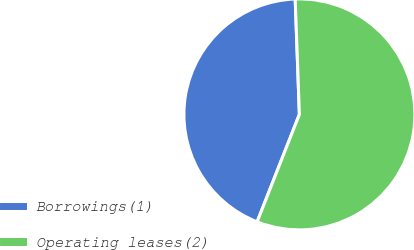Convert chart. <chart><loc_0><loc_0><loc_500><loc_500><pie_chart><fcel>Borrowings(1)<fcel>Operating leases(2)<nl><fcel>43.46%<fcel>56.54%<nl></chart> 